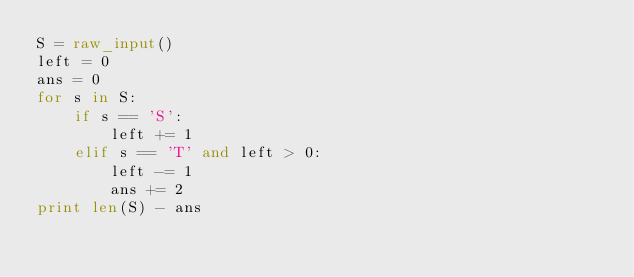Convert code to text. <code><loc_0><loc_0><loc_500><loc_500><_Python_>S = raw_input()
left = 0
ans = 0
for s in S:
    if s == 'S':
        left += 1
    elif s == 'T' and left > 0:
        left -= 1
        ans += 2
print len(S) - ans
</code> 